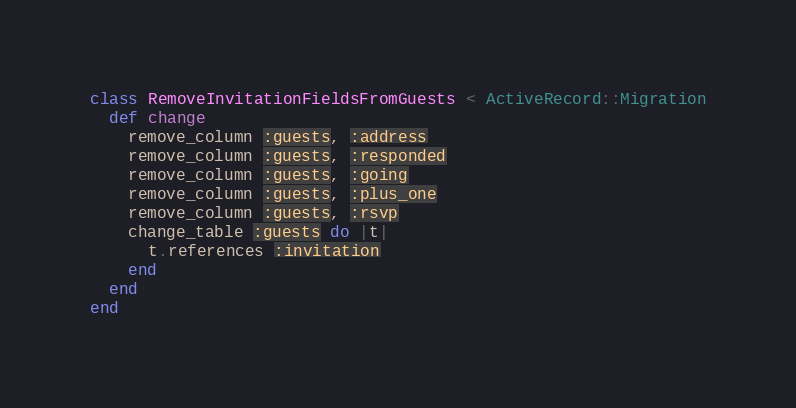<code> <loc_0><loc_0><loc_500><loc_500><_Ruby_>class RemoveInvitationFieldsFromGuests < ActiveRecord::Migration
  def change
    remove_column :guests, :address
    remove_column :guests, :responded
    remove_column :guests, :going
    remove_column :guests, :plus_one
    remove_column :guests, :rsvp
    change_table :guests do |t|
      t.references :invitation
    end
  end
end
</code> 